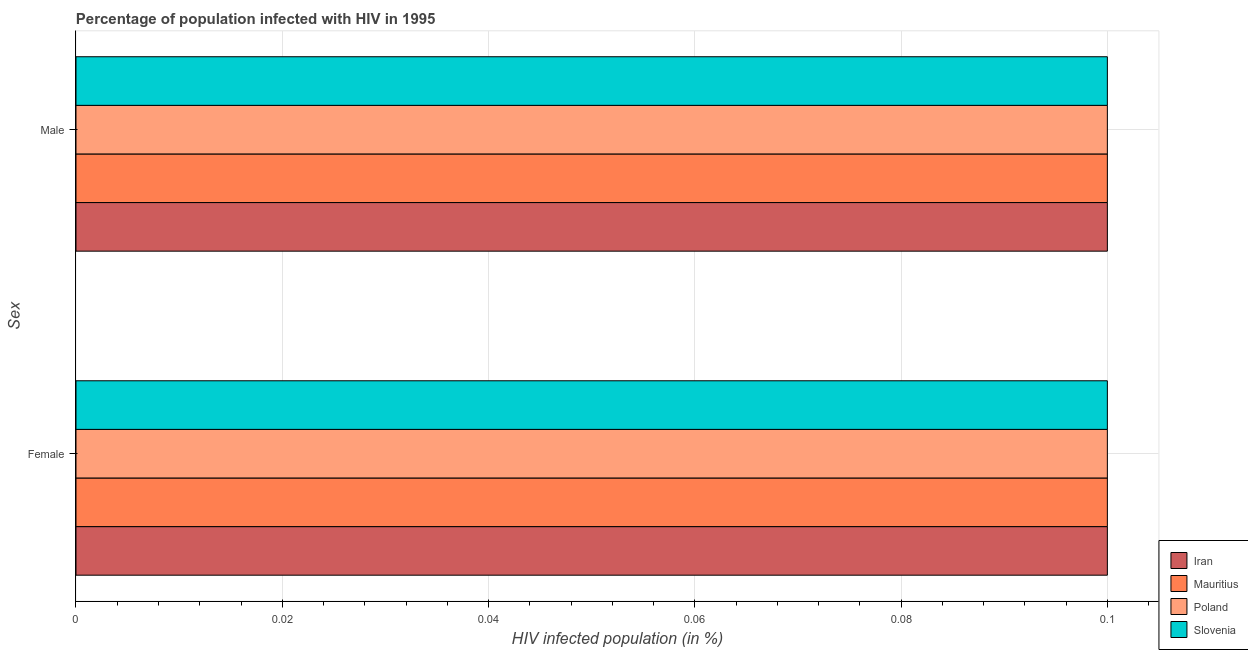Are the number of bars per tick equal to the number of legend labels?
Your response must be concise. Yes. How many bars are there on the 1st tick from the top?
Provide a succinct answer. 4. How many bars are there on the 2nd tick from the bottom?
Offer a very short reply. 4. What is the label of the 2nd group of bars from the top?
Your response must be concise. Female. What is the percentage of females who are infected with hiv in Poland?
Make the answer very short. 0.1. Across all countries, what is the minimum percentage of males who are infected with hiv?
Provide a succinct answer. 0.1. In which country was the percentage of females who are infected with hiv maximum?
Your answer should be very brief. Iran. In which country was the percentage of females who are infected with hiv minimum?
Offer a terse response. Iran. What is the total percentage of males who are infected with hiv in the graph?
Make the answer very short. 0.4. What is the difference between the percentage of males who are infected with hiv and percentage of females who are infected with hiv in Slovenia?
Offer a terse response. 0. Is the percentage of females who are infected with hiv in Mauritius less than that in Slovenia?
Your answer should be very brief. No. In how many countries, is the percentage of females who are infected with hiv greater than the average percentage of females who are infected with hiv taken over all countries?
Keep it short and to the point. 0. What does the 4th bar from the top in Male represents?
Give a very brief answer. Iran. How many bars are there?
Give a very brief answer. 8. Are all the bars in the graph horizontal?
Keep it short and to the point. Yes. How many countries are there in the graph?
Provide a succinct answer. 4. What is the difference between two consecutive major ticks on the X-axis?
Provide a succinct answer. 0.02. Where does the legend appear in the graph?
Your answer should be very brief. Bottom right. How many legend labels are there?
Offer a terse response. 4. What is the title of the graph?
Your response must be concise. Percentage of population infected with HIV in 1995. Does "Nepal" appear as one of the legend labels in the graph?
Offer a terse response. No. What is the label or title of the X-axis?
Provide a short and direct response. HIV infected population (in %). What is the label or title of the Y-axis?
Provide a short and direct response. Sex. What is the HIV infected population (in %) of Iran in Female?
Keep it short and to the point. 0.1. What is the HIV infected population (in %) in Mauritius in Female?
Give a very brief answer. 0.1. What is the HIV infected population (in %) of Poland in Female?
Ensure brevity in your answer.  0.1. What is the HIV infected population (in %) of Mauritius in Male?
Offer a very short reply. 0.1. What is the HIV infected population (in %) in Poland in Male?
Your answer should be compact. 0.1. What is the HIV infected population (in %) of Slovenia in Male?
Provide a short and direct response. 0.1. Across all Sex, what is the maximum HIV infected population (in %) of Iran?
Offer a very short reply. 0.1. Across all Sex, what is the maximum HIV infected population (in %) in Mauritius?
Your response must be concise. 0.1. Across all Sex, what is the minimum HIV infected population (in %) of Iran?
Keep it short and to the point. 0.1. Across all Sex, what is the minimum HIV infected population (in %) in Mauritius?
Your answer should be compact. 0.1. Across all Sex, what is the minimum HIV infected population (in %) in Poland?
Your response must be concise. 0.1. What is the total HIV infected population (in %) in Iran in the graph?
Your answer should be compact. 0.2. What is the total HIV infected population (in %) in Slovenia in the graph?
Your response must be concise. 0.2. What is the difference between the HIV infected population (in %) of Mauritius in Female and that in Male?
Give a very brief answer. 0. What is the difference between the HIV infected population (in %) in Iran in Female and the HIV infected population (in %) in Mauritius in Male?
Your response must be concise. 0. What is the difference between the HIV infected population (in %) in Mauritius in Female and the HIV infected population (in %) in Poland in Male?
Provide a succinct answer. 0. What is the difference between the HIV infected population (in %) in Poland in Female and the HIV infected population (in %) in Slovenia in Male?
Offer a very short reply. 0. What is the average HIV infected population (in %) of Poland per Sex?
Offer a very short reply. 0.1. What is the difference between the HIV infected population (in %) in Poland and HIV infected population (in %) in Slovenia in Female?
Give a very brief answer. 0. What is the difference between the HIV infected population (in %) in Iran and HIV infected population (in %) in Poland in Male?
Provide a succinct answer. 0. What is the difference between the HIV infected population (in %) in Iran and HIV infected population (in %) in Slovenia in Male?
Offer a very short reply. 0. What is the difference between the HIV infected population (in %) in Mauritius and HIV infected population (in %) in Poland in Male?
Your answer should be very brief. 0. What is the difference between the HIV infected population (in %) in Mauritius and HIV infected population (in %) in Slovenia in Male?
Offer a terse response. 0. What is the difference between the HIV infected population (in %) in Poland and HIV infected population (in %) in Slovenia in Male?
Offer a very short reply. 0. What is the ratio of the HIV infected population (in %) in Poland in Female to that in Male?
Give a very brief answer. 1. What is the difference between the highest and the second highest HIV infected population (in %) of Iran?
Give a very brief answer. 0. What is the difference between the highest and the second highest HIV infected population (in %) in Poland?
Ensure brevity in your answer.  0. What is the difference between the highest and the lowest HIV infected population (in %) of Iran?
Provide a succinct answer. 0. What is the difference between the highest and the lowest HIV infected population (in %) of Poland?
Provide a short and direct response. 0. 